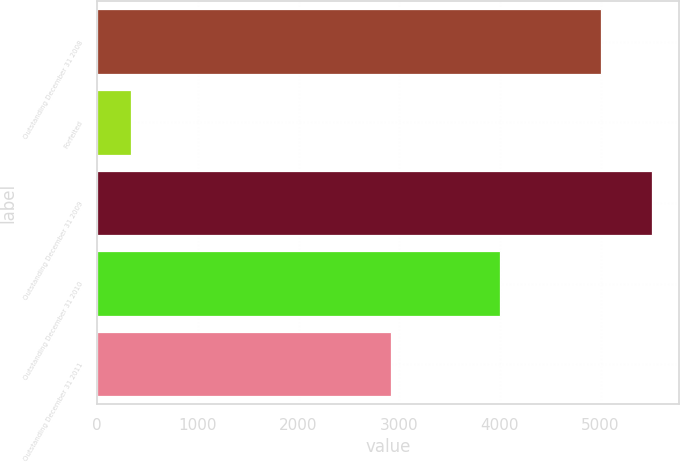Convert chart. <chart><loc_0><loc_0><loc_500><loc_500><bar_chart><fcel>Outstanding December 31 2008<fcel>Forfeited<fcel>Outstanding December 31 2009<fcel>Outstanding December 31 2010<fcel>Outstanding December 31 2011<nl><fcel>5002<fcel>335<fcel>5505.4<fcel>3996<fcel>2915<nl></chart> 